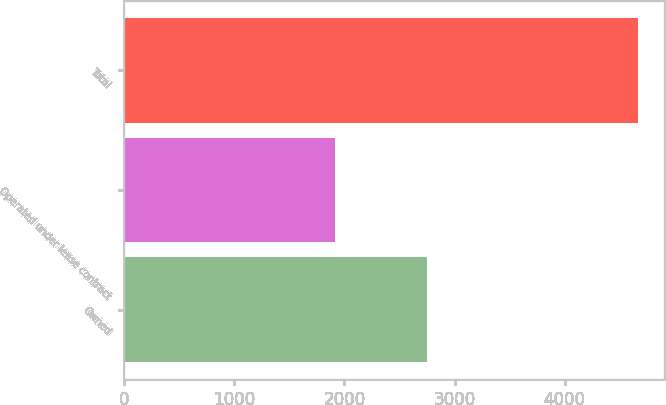Convert chart. <chart><loc_0><loc_0><loc_500><loc_500><bar_chart><fcel>Owned<fcel>Operated under lease contract<fcel>Total<nl><fcel>2754<fcel>1916<fcel>4670<nl></chart> 